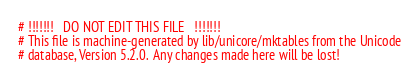<code> <loc_0><loc_0><loc_500><loc_500><_Perl_># !!!!!!!   DO NOT EDIT THIS FILE   !!!!!!!
# This file is machine-generated by lib/unicore/mktables from the Unicode
# database, Version 5.2.0.  Any changes made here will be lost!
</code> 